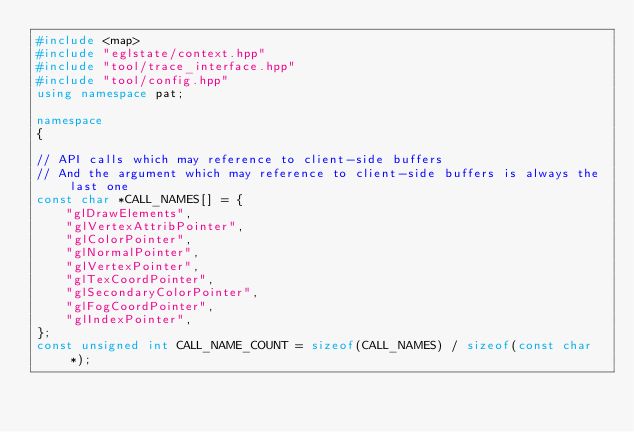Convert code to text. <code><loc_0><loc_0><loc_500><loc_500><_C++_>#include <map>
#include "eglstate/context.hpp"
#include "tool/trace_interface.hpp"
#include "tool/config.hpp"
using namespace pat;

namespace
{

// API calls which may reference to client-side buffers
// And the argument which may reference to client-side buffers is always the last one
const char *CALL_NAMES[] = {
    "glDrawElements",
    "glVertexAttribPointer",
    "glColorPointer",
    "glNormalPointer",
    "glVertexPointer",
    "glTexCoordPointer",
    "glSecondaryColorPointer",
    "glFogCoordPointer",
    "glIndexPointer",
};
const unsigned int CALL_NAME_COUNT = sizeof(CALL_NAMES) / sizeof(const char *);
</code> 